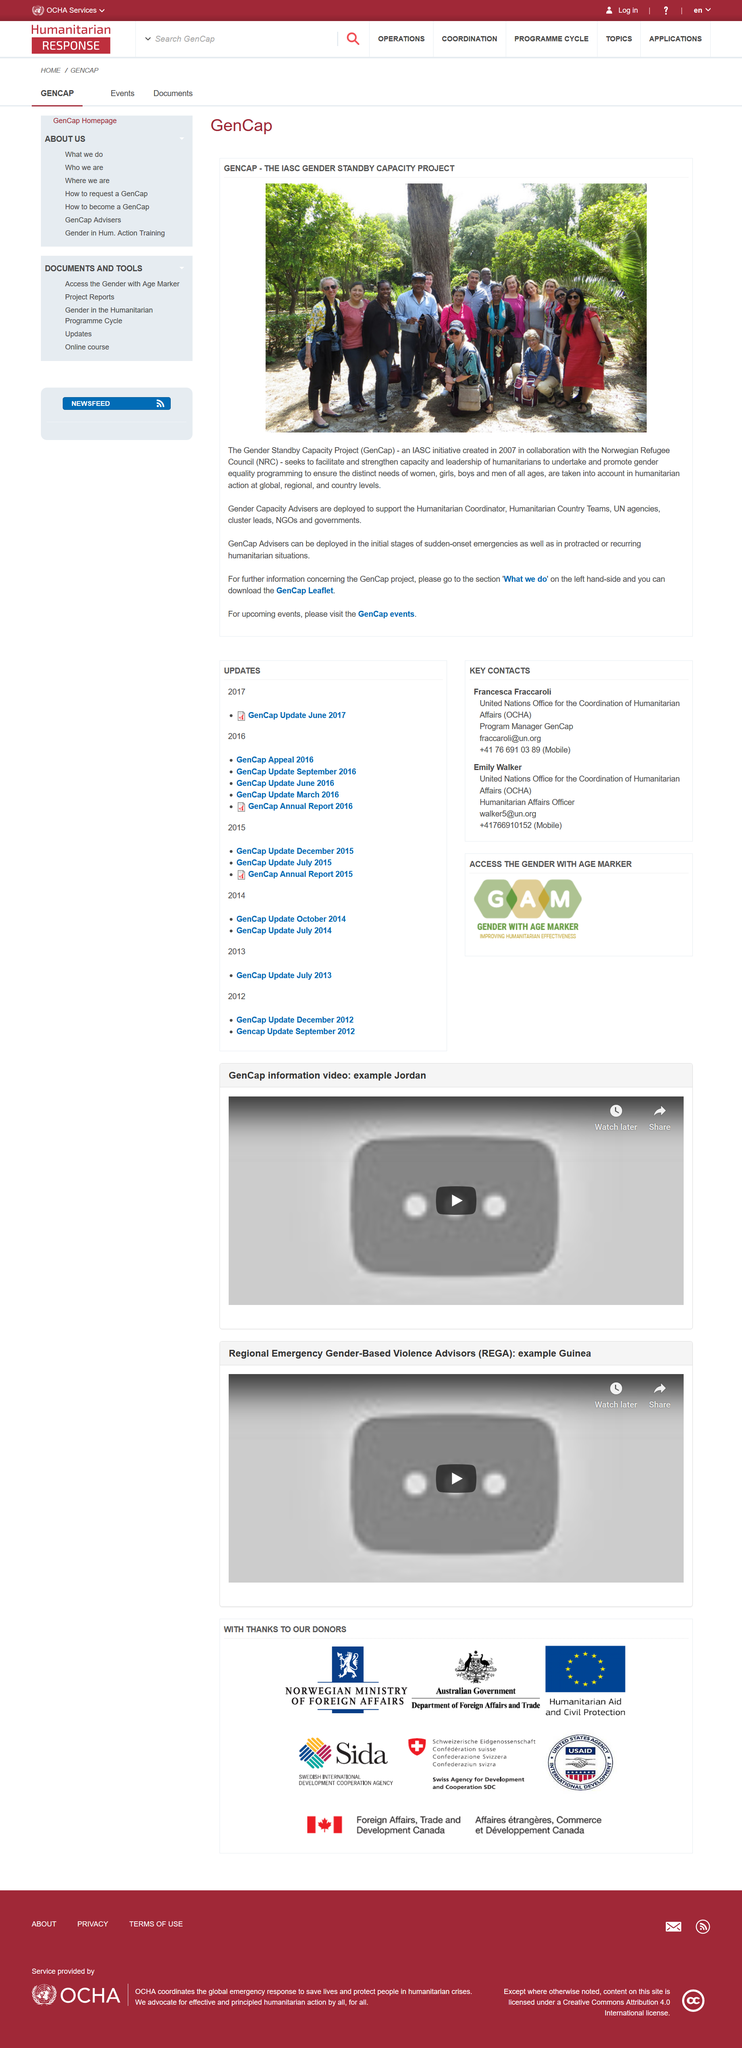Highlight a few significant elements in this photo. The GenCap project can be further researched through its 'What we do' section, where additional information can be obtained, and a GenCap Leaflet can be downloaded for further understanding. The GenCap initiative is dedicated to promoting gender equality programming for all members of society, regardless of age or gender. We aim to empower women, girls, boys, and men by providing education, resources, and opportunities to achieve equality and live fulfilling lives. Through our efforts, we strive to create a more just and equitable world for all. In 2007, the GenCap initiative was established. 